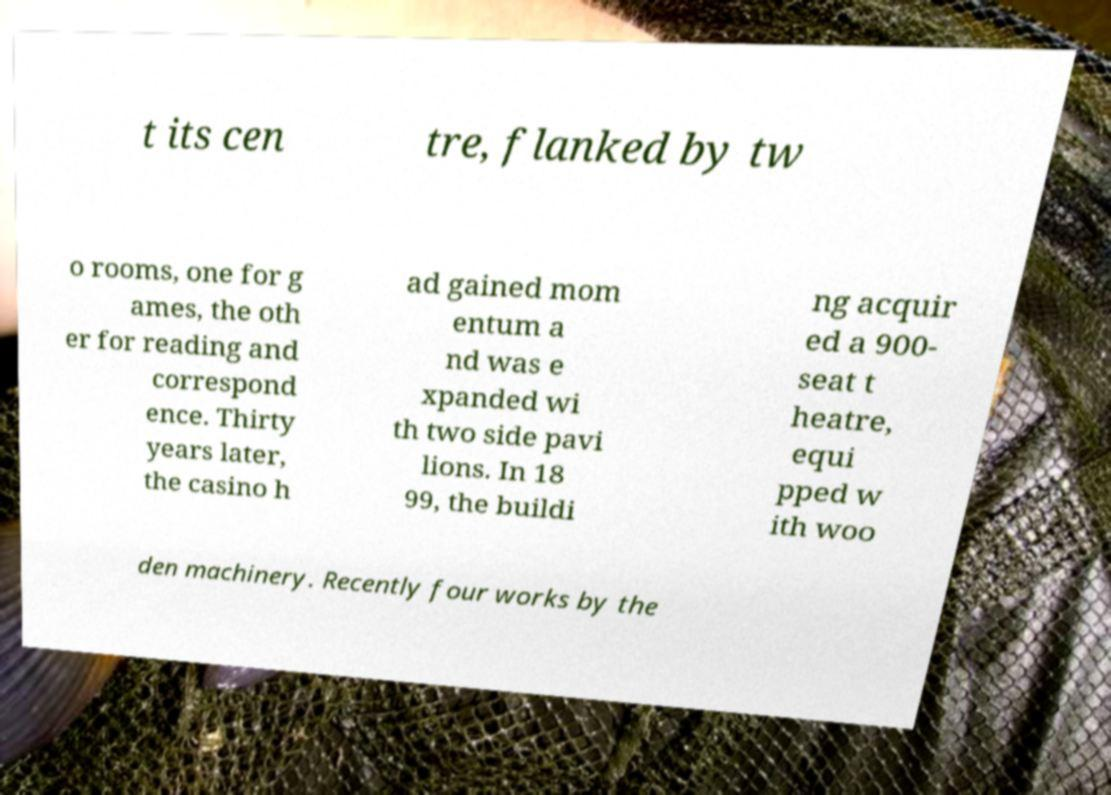For documentation purposes, I need the text within this image transcribed. Could you provide that? t its cen tre, flanked by tw o rooms, one for g ames, the oth er for reading and correspond ence. Thirty years later, the casino h ad gained mom entum a nd was e xpanded wi th two side pavi lions. In 18 99, the buildi ng acquir ed a 900- seat t heatre, equi pped w ith woo den machinery. Recently four works by the 